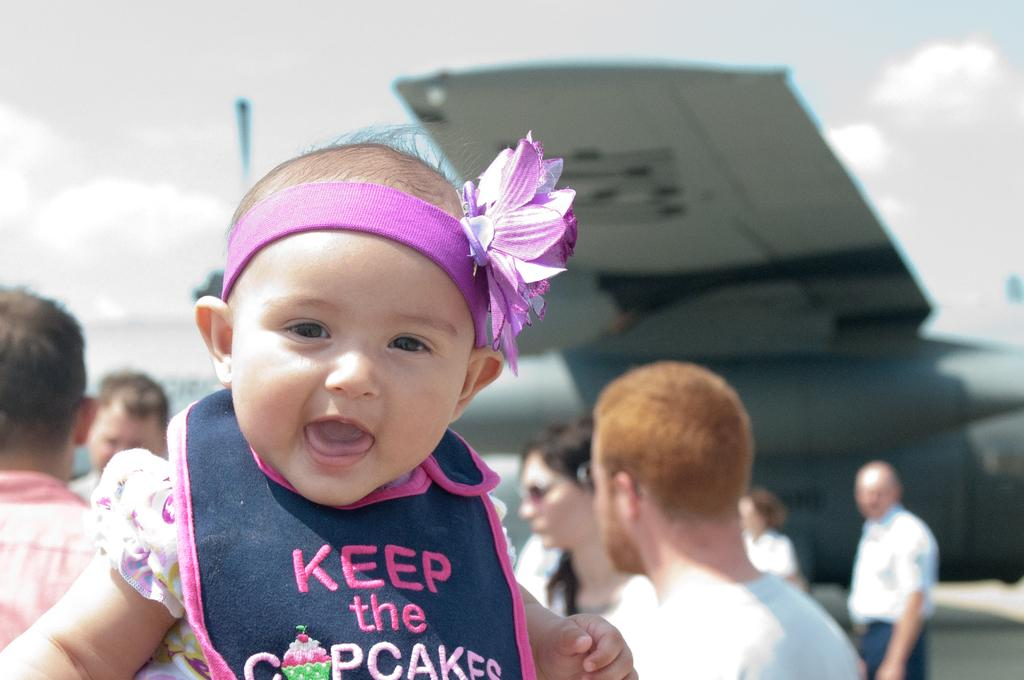What is the main subject of the image? There is a baby in the image. What is the baby wearing? The baby is wearing a violet jacket. What can be seen in the background of the image? There are persons and an aircraft in the background of the image. What is visible in the sky in the background of the image? There are clouds in the sky in the background of the image. Where is the flock of birds flying in the image? There are no birds visible in the image, so it is not possible to determine where a flock of birds might be flying. 